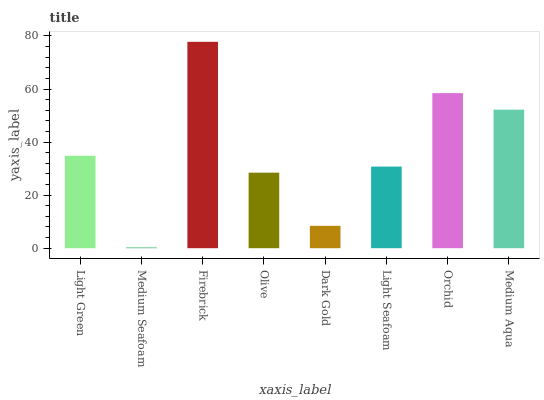Is Medium Seafoam the minimum?
Answer yes or no. Yes. Is Firebrick the maximum?
Answer yes or no. Yes. Is Firebrick the minimum?
Answer yes or no. No. Is Medium Seafoam the maximum?
Answer yes or no. No. Is Firebrick greater than Medium Seafoam?
Answer yes or no. Yes. Is Medium Seafoam less than Firebrick?
Answer yes or no. Yes. Is Medium Seafoam greater than Firebrick?
Answer yes or no. No. Is Firebrick less than Medium Seafoam?
Answer yes or no. No. Is Light Green the high median?
Answer yes or no. Yes. Is Light Seafoam the low median?
Answer yes or no. Yes. Is Light Seafoam the high median?
Answer yes or no. No. Is Olive the low median?
Answer yes or no. No. 